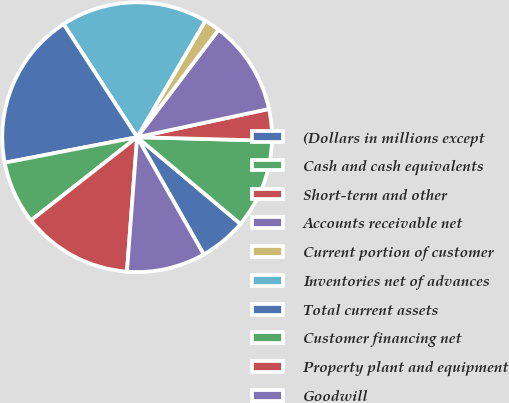<chart> <loc_0><loc_0><loc_500><loc_500><pie_chart><fcel>(Dollars in millions except<fcel>Cash and cash equivalents<fcel>Short-term and other<fcel>Accounts receivable net<fcel>Current portion of customer<fcel>Inventories net of advances<fcel>Total current assets<fcel>Customer financing net<fcel>Property plant and equipment<fcel>Goodwill<nl><fcel>5.66%<fcel>10.69%<fcel>3.78%<fcel>11.32%<fcel>1.89%<fcel>17.61%<fcel>18.86%<fcel>7.55%<fcel>13.21%<fcel>9.43%<nl></chart> 